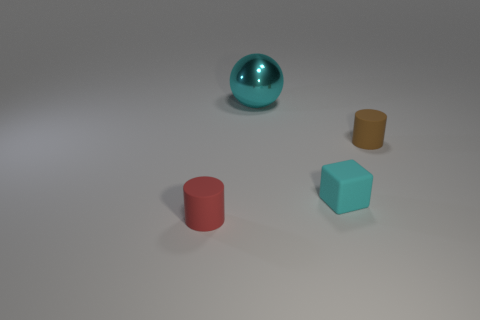What number of other things are made of the same material as the cyan ball?
Make the answer very short. 0. What color is the tiny cylinder on the left side of the metal object?
Keep it short and to the point. Red. How many matte things are either spheres or big blue things?
Offer a terse response. 0. There is a cylinder that is on the right side of the cylinder that is left of the brown rubber cylinder; what is its material?
Your answer should be very brief. Rubber. What material is the cube that is the same color as the big metal thing?
Provide a succinct answer. Rubber. Is there a rubber cylinder behind the tiny rubber cylinder that is to the right of the small red object?
Make the answer very short. No. What is the material of the sphere?
Your answer should be very brief. Metal. Does the cube that is to the left of the small brown cylinder have the same material as the thing that is behind the small brown cylinder?
Offer a very short reply. No. Is there anything else that is the same color as the metal ball?
Offer a very short reply. Yes. The other thing that is the same shape as the small red thing is what color?
Make the answer very short. Brown. 